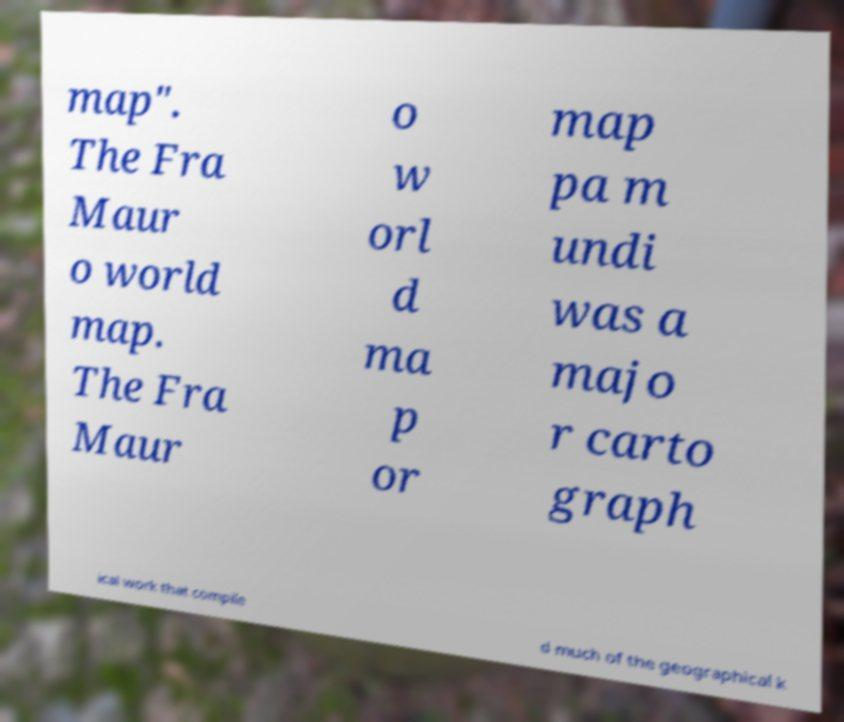I need the written content from this picture converted into text. Can you do that? map". The Fra Maur o world map. The Fra Maur o w orl d ma p or map pa m undi was a majo r carto graph ical work that compile d much of the geographical k 